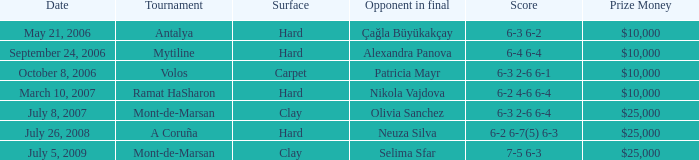What is the date of the match on clay with score of 6-3 2-6 6-4? July 8, 2007. 